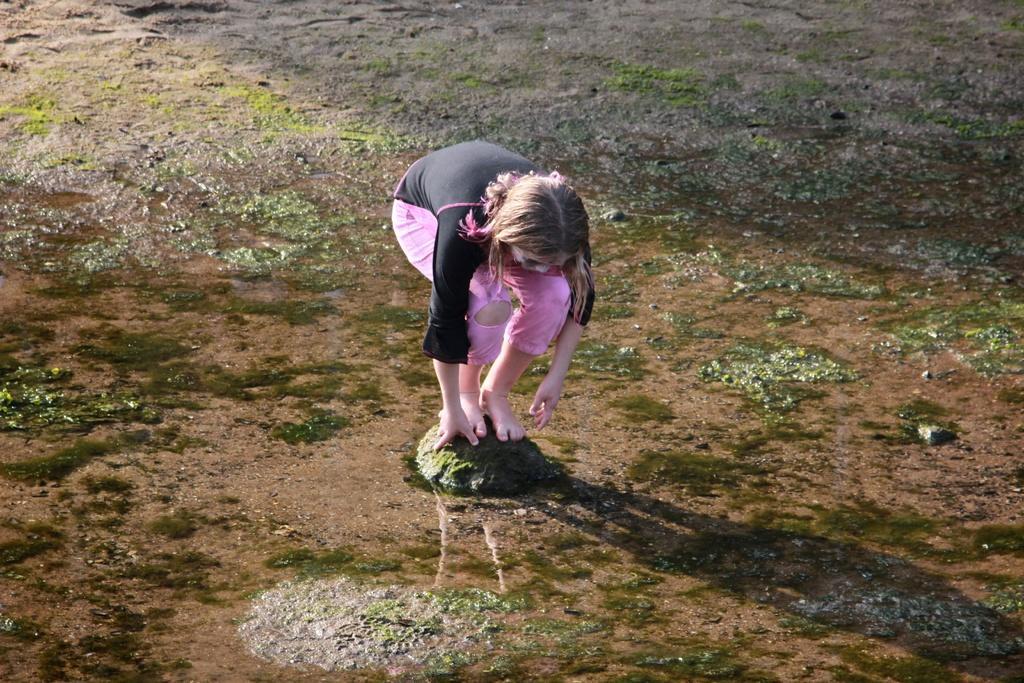In one or two sentences, can you explain what this image depicts? In this image I can see a girl wearing black and pink colored dress is standing on a rock which is green in color. I can see the water, the ground and some grass. 